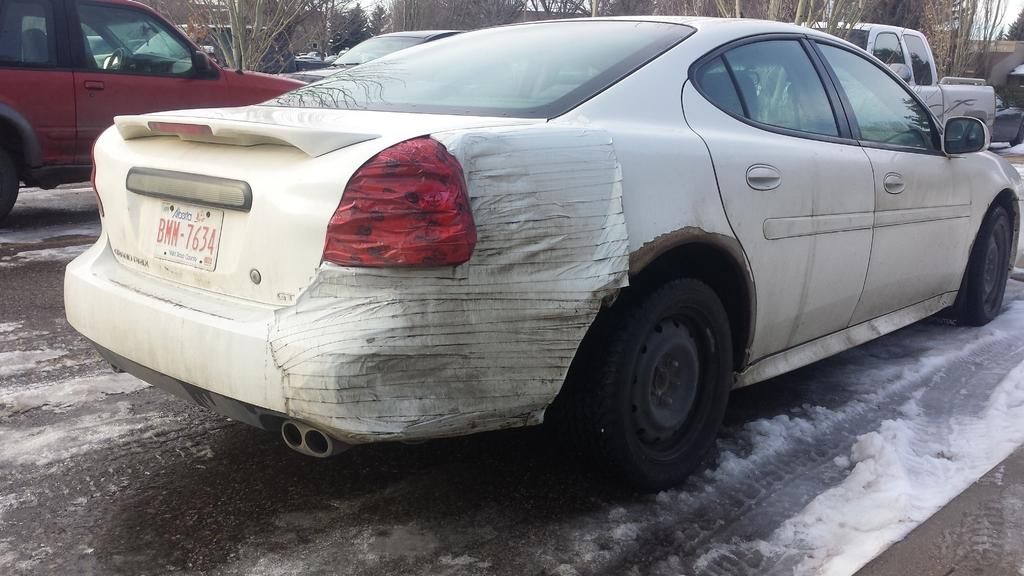What is happening on the road in the image? There are vehicles on the road in the image. What is the condition of the road in the image? There is snow on the road in the image. What can be seen in the background of the image? There are trees visible in the background of the image. What type of gold jewelry is the person wearing in the image? There is no person or gold jewelry present in the image; it features vehicles on a snowy road with trees in the background. 